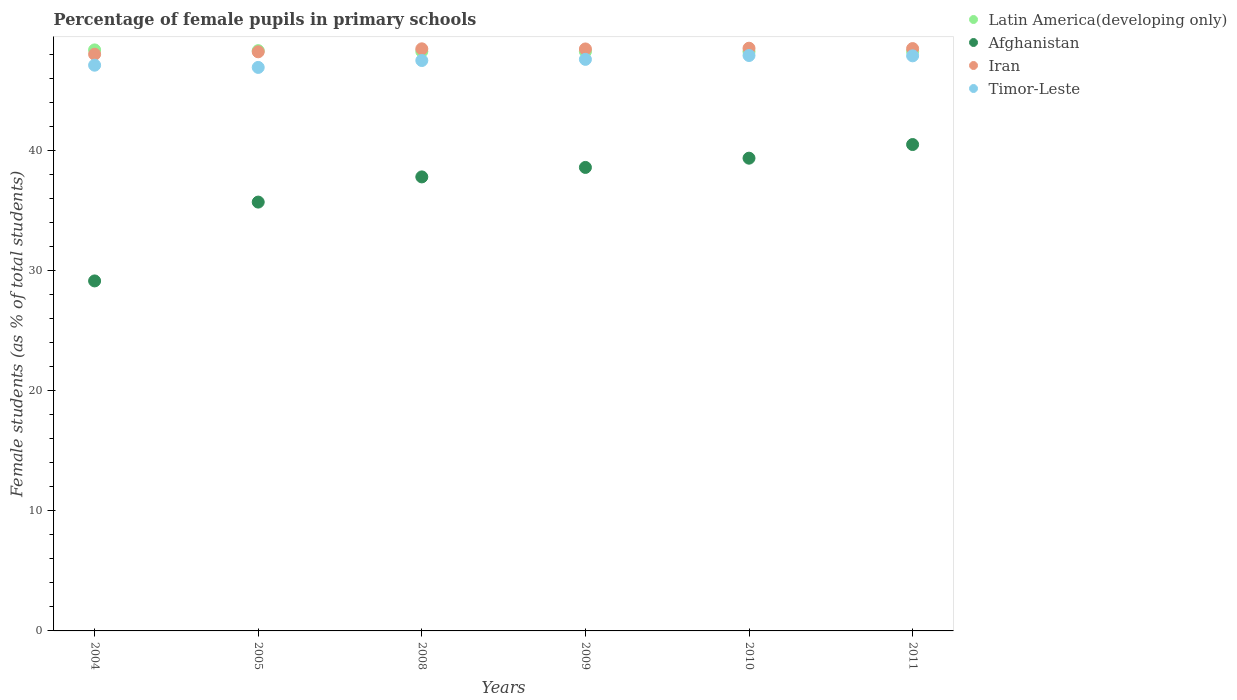Is the number of dotlines equal to the number of legend labels?
Keep it short and to the point. Yes. What is the percentage of female pupils in primary schools in Afghanistan in 2004?
Offer a very short reply. 29.13. Across all years, what is the maximum percentage of female pupils in primary schools in Timor-Leste?
Provide a succinct answer. 47.88. Across all years, what is the minimum percentage of female pupils in primary schools in Timor-Leste?
Provide a short and direct response. 46.89. In which year was the percentage of female pupils in primary schools in Latin America(developing only) maximum?
Give a very brief answer. 2004. In which year was the percentage of female pupils in primary schools in Timor-Leste minimum?
Keep it short and to the point. 2005. What is the total percentage of female pupils in primary schools in Iran in the graph?
Your response must be concise. 290.01. What is the difference between the percentage of female pupils in primary schools in Timor-Leste in 2009 and that in 2011?
Make the answer very short. -0.29. What is the difference between the percentage of female pupils in primary schools in Timor-Leste in 2004 and the percentage of female pupils in primary schools in Latin America(developing only) in 2010?
Your response must be concise. -1.14. What is the average percentage of female pupils in primary schools in Afghanistan per year?
Offer a terse response. 36.83. In the year 2008, what is the difference between the percentage of female pupils in primary schools in Timor-Leste and percentage of female pupils in primary schools in Afghanistan?
Offer a very short reply. 9.68. What is the ratio of the percentage of female pupils in primary schools in Iran in 2009 to that in 2011?
Make the answer very short. 1. Is the percentage of female pupils in primary schools in Afghanistan in 2004 less than that in 2009?
Provide a short and direct response. Yes. What is the difference between the highest and the second highest percentage of female pupils in primary schools in Timor-Leste?
Give a very brief answer. 0.03. What is the difference between the highest and the lowest percentage of female pupils in primary schools in Iran?
Your answer should be compact. 0.5. In how many years, is the percentage of female pupils in primary schools in Afghanistan greater than the average percentage of female pupils in primary schools in Afghanistan taken over all years?
Your response must be concise. 4. Is it the case that in every year, the sum of the percentage of female pupils in primary schools in Timor-Leste and percentage of female pupils in primary schools in Iran  is greater than the sum of percentage of female pupils in primary schools in Latin America(developing only) and percentage of female pupils in primary schools in Afghanistan?
Offer a terse response. Yes. Is it the case that in every year, the sum of the percentage of female pupils in primary schools in Timor-Leste and percentage of female pupils in primary schools in Iran  is greater than the percentage of female pupils in primary schools in Afghanistan?
Make the answer very short. Yes. How many years are there in the graph?
Ensure brevity in your answer.  6. Are the values on the major ticks of Y-axis written in scientific E-notation?
Keep it short and to the point. No. Does the graph contain any zero values?
Provide a succinct answer. No. Does the graph contain grids?
Your answer should be very brief. No. Where does the legend appear in the graph?
Your answer should be compact. Top right. How many legend labels are there?
Offer a very short reply. 4. What is the title of the graph?
Make the answer very short. Percentage of female pupils in primary schools. Does "Rwanda" appear as one of the legend labels in the graph?
Your answer should be compact. No. What is the label or title of the X-axis?
Keep it short and to the point. Years. What is the label or title of the Y-axis?
Your answer should be very brief. Female students (as % of total students). What is the Female students (as % of total students) of Latin America(developing only) in 2004?
Provide a succinct answer. 48.35. What is the Female students (as % of total students) in Afghanistan in 2004?
Make the answer very short. 29.13. What is the Female students (as % of total students) of Iran in 2004?
Give a very brief answer. 47.99. What is the Female students (as % of total students) in Timor-Leste in 2004?
Give a very brief answer. 47.08. What is the Female students (as % of total students) of Latin America(developing only) in 2005?
Your answer should be compact. 48.29. What is the Female students (as % of total students) of Afghanistan in 2005?
Make the answer very short. 35.69. What is the Female students (as % of total students) in Iran in 2005?
Provide a succinct answer. 48.19. What is the Female students (as % of total students) in Timor-Leste in 2005?
Your response must be concise. 46.89. What is the Female students (as % of total students) of Latin America(developing only) in 2008?
Give a very brief answer. 48.22. What is the Female students (as % of total students) of Afghanistan in 2008?
Your answer should be very brief. 37.78. What is the Female students (as % of total students) in Iran in 2008?
Provide a succinct answer. 48.44. What is the Female students (as % of total students) in Timor-Leste in 2008?
Your answer should be compact. 47.47. What is the Female students (as % of total students) of Latin America(developing only) in 2009?
Give a very brief answer. 48.21. What is the Female students (as % of total students) in Afghanistan in 2009?
Provide a succinct answer. 38.57. What is the Female students (as % of total students) in Iran in 2009?
Your answer should be very brief. 48.43. What is the Female students (as % of total students) of Timor-Leste in 2009?
Your answer should be very brief. 47.56. What is the Female students (as % of total students) in Latin America(developing only) in 2010?
Make the answer very short. 48.21. What is the Female students (as % of total students) of Afghanistan in 2010?
Offer a very short reply. 39.34. What is the Female students (as % of total students) of Iran in 2010?
Your answer should be compact. 48.49. What is the Female students (as % of total students) of Timor-Leste in 2010?
Ensure brevity in your answer.  47.88. What is the Female students (as % of total students) in Latin America(developing only) in 2011?
Provide a short and direct response. 48.22. What is the Female students (as % of total students) in Afghanistan in 2011?
Your answer should be compact. 40.48. What is the Female students (as % of total students) in Iran in 2011?
Offer a terse response. 48.46. What is the Female students (as % of total students) in Timor-Leste in 2011?
Make the answer very short. 47.86. Across all years, what is the maximum Female students (as % of total students) of Latin America(developing only)?
Your response must be concise. 48.35. Across all years, what is the maximum Female students (as % of total students) of Afghanistan?
Ensure brevity in your answer.  40.48. Across all years, what is the maximum Female students (as % of total students) in Iran?
Keep it short and to the point. 48.49. Across all years, what is the maximum Female students (as % of total students) in Timor-Leste?
Keep it short and to the point. 47.88. Across all years, what is the minimum Female students (as % of total students) in Latin America(developing only)?
Give a very brief answer. 48.21. Across all years, what is the minimum Female students (as % of total students) of Afghanistan?
Your answer should be compact. 29.13. Across all years, what is the minimum Female students (as % of total students) of Iran?
Ensure brevity in your answer.  47.99. Across all years, what is the minimum Female students (as % of total students) of Timor-Leste?
Offer a very short reply. 46.89. What is the total Female students (as % of total students) of Latin America(developing only) in the graph?
Make the answer very short. 289.51. What is the total Female students (as % of total students) of Afghanistan in the graph?
Offer a very short reply. 220.98. What is the total Female students (as % of total students) of Iran in the graph?
Give a very brief answer. 290.01. What is the total Female students (as % of total students) in Timor-Leste in the graph?
Give a very brief answer. 284.75. What is the difference between the Female students (as % of total students) of Latin America(developing only) in 2004 and that in 2005?
Your answer should be compact. 0.06. What is the difference between the Female students (as % of total students) of Afghanistan in 2004 and that in 2005?
Offer a very short reply. -6.56. What is the difference between the Female students (as % of total students) in Iran in 2004 and that in 2005?
Your response must be concise. -0.2. What is the difference between the Female students (as % of total students) of Timor-Leste in 2004 and that in 2005?
Keep it short and to the point. 0.18. What is the difference between the Female students (as % of total students) of Latin America(developing only) in 2004 and that in 2008?
Provide a succinct answer. 0.13. What is the difference between the Female students (as % of total students) of Afghanistan in 2004 and that in 2008?
Your answer should be very brief. -8.66. What is the difference between the Female students (as % of total students) in Iran in 2004 and that in 2008?
Keep it short and to the point. -0.45. What is the difference between the Female students (as % of total students) in Timor-Leste in 2004 and that in 2008?
Your response must be concise. -0.39. What is the difference between the Female students (as % of total students) in Latin America(developing only) in 2004 and that in 2009?
Give a very brief answer. 0.14. What is the difference between the Female students (as % of total students) of Afghanistan in 2004 and that in 2009?
Offer a terse response. -9.44. What is the difference between the Female students (as % of total students) of Iran in 2004 and that in 2009?
Your answer should be very brief. -0.44. What is the difference between the Female students (as % of total students) in Timor-Leste in 2004 and that in 2009?
Your answer should be compact. -0.49. What is the difference between the Female students (as % of total students) of Latin America(developing only) in 2004 and that in 2010?
Your answer should be compact. 0.14. What is the difference between the Female students (as % of total students) of Afghanistan in 2004 and that in 2010?
Offer a very short reply. -10.21. What is the difference between the Female students (as % of total students) in Iran in 2004 and that in 2010?
Make the answer very short. -0.5. What is the difference between the Female students (as % of total students) in Timor-Leste in 2004 and that in 2010?
Provide a succinct answer. -0.81. What is the difference between the Female students (as % of total students) in Latin America(developing only) in 2004 and that in 2011?
Ensure brevity in your answer.  0.13. What is the difference between the Female students (as % of total students) in Afghanistan in 2004 and that in 2011?
Offer a very short reply. -11.35. What is the difference between the Female students (as % of total students) of Iran in 2004 and that in 2011?
Provide a succinct answer. -0.47. What is the difference between the Female students (as % of total students) in Timor-Leste in 2004 and that in 2011?
Provide a short and direct response. -0.78. What is the difference between the Female students (as % of total students) of Latin America(developing only) in 2005 and that in 2008?
Give a very brief answer. 0.07. What is the difference between the Female students (as % of total students) in Afghanistan in 2005 and that in 2008?
Your response must be concise. -2.1. What is the difference between the Female students (as % of total students) in Iran in 2005 and that in 2008?
Provide a succinct answer. -0.25. What is the difference between the Female students (as % of total students) of Timor-Leste in 2005 and that in 2008?
Offer a very short reply. -0.57. What is the difference between the Female students (as % of total students) of Latin America(developing only) in 2005 and that in 2009?
Your response must be concise. 0.08. What is the difference between the Female students (as % of total students) of Afghanistan in 2005 and that in 2009?
Your answer should be compact. -2.88. What is the difference between the Female students (as % of total students) in Iran in 2005 and that in 2009?
Your answer should be compact. -0.24. What is the difference between the Female students (as % of total students) of Timor-Leste in 2005 and that in 2009?
Your response must be concise. -0.67. What is the difference between the Female students (as % of total students) in Latin America(developing only) in 2005 and that in 2010?
Offer a terse response. 0.08. What is the difference between the Female students (as % of total students) of Afghanistan in 2005 and that in 2010?
Keep it short and to the point. -3.65. What is the difference between the Female students (as % of total students) in Iran in 2005 and that in 2010?
Your answer should be very brief. -0.3. What is the difference between the Female students (as % of total students) in Timor-Leste in 2005 and that in 2010?
Keep it short and to the point. -0.99. What is the difference between the Female students (as % of total students) of Latin America(developing only) in 2005 and that in 2011?
Keep it short and to the point. 0.07. What is the difference between the Female students (as % of total students) of Afghanistan in 2005 and that in 2011?
Your response must be concise. -4.79. What is the difference between the Female students (as % of total students) of Iran in 2005 and that in 2011?
Your response must be concise. -0.27. What is the difference between the Female students (as % of total students) of Timor-Leste in 2005 and that in 2011?
Your answer should be compact. -0.96. What is the difference between the Female students (as % of total students) of Latin America(developing only) in 2008 and that in 2009?
Your answer should be very brief. 0.01. What is the difference between the Female students (as % of total students) of Afghanistan in 2008 and that in 2009?
Make the answer very short. -0.79. What is the difference between the Female students (as % of total students) in Iran in 2008 and that in 2009?
Ensure brevity in your answer.  0.01. What is the difference between the Female students (as % of total students) of Timor-Leste in 2008 and that in 2009?
Give a very brief answer. -0.1. What is the difference between the Female students (as % of total students) in Latin America(developing only) in 2008 and that in 2010?
Offer a terse response. 0.01. What is the difference between the Female students (as % of total students) of Afghanistan in 2008 and that in 2010?
Provide a succinct answer. -1.56. What is the difference between the Female students (as % of total students) of Iran in 2008 and that in 2010?
Provide a short and direct response. -0.05. What is the difference between the Female students (as % of total students) of Timor-Leste in 2008 and that in 2010?
Give a very brief answer. -0.42. What is the difference between the Female students (as % of total students) of Latin America(developing only) in 2008 and that in 2011?
Offer a terse response. -0. What is the difference between the Female students (as % of total students) in Afghanistan in 2008 and that in 2011?
Keep it short and to the point. -2.69. What is the difference between the Female students (as % of total students) of Iran in 2008 and that in 2011?
Provide a short and direct response. -0.02. What is the difference between the Female students (as % of total students) in Timor-Leste in 2008 and that in 2011?
Give a very brief answer. -0.39. What is the difference between the Female students (as % of total students) in Latin America(developing only) in 2009 and that in 2010?
Ensure brevity in your answer.  -0. What is the difference between the Female students (as % of total students) in Afghanistan in 2009 and that in 2010?
Offer a terse response. -0.77. What is the difference between the Female students (as % of total students) in Iran in 2009 and that in 2010?
Give a very brief answer. -0.06. What is the difference between the Female students (as % of total students) of Timor-Leste in 2009 and that in 2010?
Offer a very short reply. -0.32. What is the difference between the Female students (as % of total students) of Latin America(developing only) in 2009 and that in 2011?
Ensure brevity in your answer.  -0.01. What is the difference between the Female students (as % of total students) in Afghanistan in 2009 and that in 2011?
Offer a very short reply. -1.9. What is the difference between the Female students (as % of total students) of Iran in 2009 and that in 2011?
Provide a short and direct response. -0.03. What is the difference between the Female students (as % of total students) in Timor-Leste in 2009 and that in 2011?
Your response must be concise. -0.29. What is the difference between the Female students (as % of total students) of Latin America(developing only) in 2010 and that in 2011?
Provide a short and direct response. -0.01. What is the difference between the Female students (as % of total students) in Afghanistan in 2010 and that in 2011?
Offer a terse response. -1.13. What is the difference between the Female students (as % of total students) in Iran in 2010 and that in 2011?
Offer a terse response. 0.03. What is the difference between the Female students (as % of total students) in Timor-Leste in 2010 and that in 2011?
Your answer should be very brief. 0.03. What is the difference between the Female students (as % of total students) of Latin America(developing only) in 2004 and the Female students (as % of total students) of Afghanistan in 2005?
Ensure brevity in your answer.  12.66. What is the difference between the Female students (as % of total students) in Latin America(developing only) in 2004 and the Female students (as % of total students) in Iran in 2005?
Provide a short and direct response. 0.16. What is the difference between the Female students (as % of total students) in Latin America(developing only) in 2004 and the Female students (as % of total students) in Timor-Leste in 2005?
Provide a short and direct response. 1.46. What is the difference between the Female students (as % of total students) of Afghanistan in 2004 and the Female students (as % of total students) of Iran in 2005?
Give a very brief answer. -19.07. What is the difference between the Female students (as % of total students) of Afghanistan in 2004 and the Female students (as % of total students) of Timor-Leste in 2005?
Provide a short and direct response. -17.77. What is the difference between the Female students (as % of total students) of Iran in 2004 and the Female students (as % of total students) of Timor-Leste in 2005?
Make the answer very short. 1.1. What is the difference between the Female students (as % of total students) of Latin America(developing only) in 2004 and the Female students (as % of total students) of Afghanistan in 2008?
Offer a very short reply. 10.57. What is the difference between the Female students (as % of total students) in Latin America(developing only) in 2004 and the Female students (as % of total students) in Iran in 2008?
Ensure brevity in your answer.  -0.09. What is the difference between the Female students (as % of total students) in Latin America(developing only) in 2004 and the Female students (as % of total students) in Timor-Leste in 2008?
Your response must be concise. 0.88. What is the difference between the Female students (as % of total students) in Afghanistan in 2004 and the Female students (as % of total students) in Iran in 2008?
Offer a very short reply. -19.31. What is the difference between the Female students (as % of total students) of Afghanistan in 2004 and the Female students (as % of total students) of Timor-Leste in 2008?
Ensure brevity in your answer.  -18.34. What is the difference between the Female students (as % of total students) in Iran in 2004 and the Female students (as % of total students) in Timor-Leste in 2008?
Provide a succinct answer. 0.52. What is the difference between the Female students (as % of total students) of Latin America(developing only) in 2004 and the Female students (as % of total students) of Afghanistan in 2009?
Your answer should be compact. 9.78. What is the difference between the Female students (as % of total students) of Latin America(developing only) in 2004 and the Female students (as % of total students) of Iran in 2009?
Provide a succinct answer. -0.08. What is the difference between the Female students (as % of total students) in Latin America(developing only) in 2004 and the Female students (as % of total students) in Timor-Leste in 2009?
Your answer should be compact. 0.79. What is the difference between the Female students (as % of total students) in Afghanistan in 2004 and the Female students (as % of total students) in Iran in 2009?
Provide a succinct answer. -19.3. What is the difference between the Female students (as % of total students) of Afghanistan in 2004 and the Female students (as % of total students) of Timor-Leste in 2009?
Provide a succinct answer. -18.44. What is the difference between the Female students (as % of total students) of Iran in 2004 and the Female students (as % of total students) of Timor-Leste in 2009?
Your answer should be very brief. 0.43. What is the difference between the Female students (as % of total students) of Latin America(developing only) in 2004 and the Female students (as % of total students) of Afghanistan in 2010?
Provide a short and direct response. 9.01. What is the difference between the Female students (as % of total students) of Latin America(developing only) in 2004 and the Female students (as % of total students) of Iran in 2010?
Provide a short and direct response. -0.14. What is the difference between the Female students (as % of total students) in Latin America(developing only) in 2004 and the Female students (as % of total students) in Timor-Leste in 2010?
Your response must be concise. 0.47. What is the difference between the Female students (as % of total students) in Afghanistan in 2004 and the Female students (as % of total students) in Iran in 2010?
Your answer should be compact. -19.37. What is the difference between the Female students (as % of total students) in Afghanistan in 2004 and the Female students (as % of total students) in Timor-Leste in 2010?
Keep it short and to the point. -18.76. What is the difference between the Female students (as % of total students) in Iran in 2004 and the Female students (as % of total students) in Timor-Leste in 2010?
Provide a short and direct response. 0.11. What is the difference between the Female students (as % of total students) of Latin America(developing only) in 2004 and the Female students (as % of total students) of Afghanistan in 2011?
Give a very brief answer. 7.88. What is the difference between the Female students (as % of total students) in Latin America(developing only) in 2004 and the Female students (as % of total students) in Iran in 2011?
Offer a very short reply. -0.11. What is the difference between the Female students (as % of total students) in Latin America(developing only) in 2004 and the Female students (as % of total students) in Timor-Leste in 2011?
Provide a succinct answer. 0.49. What is the difference between the Female students (as % of total students) of Afghanistan in 2004 and the Female students (as % of total students) of Iran in 2011?
Offer a very short reply. -19.34. What is the difference between the Female students (as % of total students) in Afghanistan in 2004 and the Female students (as % of total students) in Timor-Leste in 2011?
Your response must be concise. -18.73. What is the difference between the Female students (as % of total students) in Iran in 2004 and the Female students (as % of total students) in Timor-Leste in 2011?
Offer a terse response. 0.13. What is the difference between the Female students (as % of total students) of Latin America(developing only) in 2005 and the Female students (as % of total students) of Afghanistan in 2008?
Your response must be concise. 10.51. What is the difference between the Female students (as % of total students) of Latin America(developing only) in 2005 and the Female students (as % of total students) of Iran in 2008?
Keep it short and to the point. -0.15. What is the difference between the Female students (as % of total students) of Latin America(developing only) in 2005 and the Female students (as % of total students) of Timor-Leste in 2008?
Offer a very short reply. 0.82. What is the difference between the Female students (as % of total students) in Afghanistan in 2005 and the Female students (as % of total students) in Iran in 2008?
Your answer should be very brief. -12.75. What is the difference between the Female students (as % of total students) of Afghanistan in 2005 and the Female students (as % of total students) of Timor-Leste in 2008?
Your answer should be very brief. -11.78. What is the difference between the Female students (as % of total students) in Iran in 2005 and the Female students (as % of total students) in Timor-Leste in 2008?
Give a very brief answer. 0.73. What is the difference between the Female students (as % of total students) of Latin America(developing only) in 2005 and the Female students (as % of total students) of Afghanistan in 2009?
Give a very brief answer. 9.72. What is the difference between the Female students (as % of total students) of Latin America(developing only) in 2005 and the Female students (as % of total students) of Iran in 2009?
Provide a succinct answer. -0.14. What is the difference between the Female students (as % of total students) of Latin America(developing only) in 2005 and the Female students (as % of total students) of Timor-Leste in 2009?
Provide a short and direct response. 0.72. What is the difference between the Female students (as % of total students) in Afghanistan in 2005 and the Female students (as % of total students) in Iran in 2009?
Your response must be concise. -12.74. What is the difference between the Female students (as % of total students) of Afghanistan in 2005 and the Female students (as % of total students) of Timor-Leste in 2009?
Offer a terse response. -11.88. What is the difference between the Female students (as % of total students) in Iran in 2005 and the Female students (as % of total students) in Timor-Leste in 2009?
Your answer should be compact. 0.63. What is the difference between the Female students (as % of total students) of Latin America(developing only) in 2005 and the Female students (as % of total students) of Afghanistan in 2010?
Make the answer very short. 8.95. What is the difference between the Female students (as % of total students) in Latin America(developing only) in 2005 and the Female students (as % of total students) in Iran in 2010?
Give a very brief answer. -0.2. What is the difference between the Female students (as % of total students) in Latin America(developing only) in 2005 and the Female students (as % of total students) in Timor-Leste in 2010?
Make the answer very short. 0.4. What is the difference between the Female students (as % of total students) of Afghanistan in 2005 and the Female students (as % of total students) of Iran in 2010?
Offer a very short reply. -12.81. What is the difference between the Female students (as % of total students) in Afghanistan in 2005 and the Female students (as % of total students) in Timor-Leste in 2010?
Make the answer very short. -12.2. What is the difference between the Female students (as % of total students) in Iran in 2005 and the Female students (as % of total students) in Timor-Leste in 2010?
Your answer should be compact. 0.31. What is the difference between the Female students (as % of total students) in Latin America(developing only) in 2005 and the Female students (as % of total students) in Afghanistan in 2011?
Ensure brevity in your answer.  7.81. What is the difference between the Female students (as % of total students) in Latin America(developing only) in 2005 and the Female students (as % of total students) in Iran in 2011?
Offer a terse response. -0.17. What is the difference between the Female students (as % of total students) in Latin America(developing only) in 2005 and the Female students (as % of total students) in Timor-Leste in 2011?
Provide a succinct answer. 0.43. What is the difference between the Female students (as % of total students) of Afghanistan in 2005 and the Female students (as % of total students) of Iran in 2011?
Provide a succinct answer. -12.77. What is the difference between the Female students (as % of total students) of Afghanistan in 2005 and the Female students (as % of total students) of Timor-Leste in 2011?
Make the answer very short. -12.17. What is the difference between the Female students (as % of total students) of Iran in 2005 and the Female students (as % of total students) of Timor-Leste in 2011?
Your response must be concise. 0.34. What is the difference between the Female students (as % of total students) of Latin America(developing only) in 2008 and the Female students (as % of total students) of Afghanistan in 2009?
Your answer should be compact. 9.65. What is the difference between the Female students (as % of total students) of Latin America(developing only) in 2008 and the Female students (as % of total students) of Iran in 2009?
Give a very brief answer. -0.21. What is the difference between the Female students (as % of total students) in Latin America(developing only) in 2008 and the Female students (as % of total students) in Timor-Leste in 2009?
Your answer should be compact. 0.66. What is the difference between the Female students (as % of total students) in Afghanistan in 2008 and the Female students (as % of total students) in Iran in 2009?
Offer a very short reply. -10.65. What is the difference between the Female students (as % of total students) in Afghanistan in 2008 and the Female students (as % of total students) in Timor-Leste in 2009?
Keep it short and to the point. -9.78. What is the difference between the Female students (as % of total students) of Iran in 2008 and the Female students (as % of total students) of Timor-Leste in 2009?
Offer a terse response. 0.88. What is the difference between the Female students (as % of total students) of Latin America(developing only) in 2008 and the Female students (as % of total students) of Afghanistan in 2010?
Make the answer very short. 8.88. What is the difference between the Female students (as % of total students) of Latin America(developing only) in 2008 and the Female students (as % of total students) of Iran in 2010?
Your response must be concise. -0.27. What is the difference between the Female students (as % of total students) in Latin America(developing only) in 2008 and the Female students (as % of total students) in Timor-Leste in 2010?
Your answer should be very brief. 0.34. What is the difference between the Female students (as % of total students) of Afghanistan in 2008 and the Female students (as % of total students) of Iran in 2010?
Provide a succinct answer. -10.71. What is the difference between the Female students (as % of total students) of Afghanistan in 2008 and the Female students (as % of total students) of Timor-Leste in 2010?
Provide a short and direct response. -10.1. What is the difference between the Female students (as % of total students) of Iran in 2008 and the Female students (as % of total students) of Timor-Leste in 2010?
Make the answer very short. 0.56. What is the difference between the Female students (as % of total students) of Latin America(developing only) in 2008 and the Female students (as % of total students) of Afghanistan in 2011?
Offer a very short reply. 7.75. What is the difference between the Female students (as % of total students) in Latin America(developing only) in 2008 and the Female students (as % of total students) in Iran in 2011?
Your answer should be very brief. -0.24. What is the difference between the Female students (as % of total students) of Latin America(developing only) in 2008 and the Female students (as % of total students) of Timor-Leste in 2011?
Offer a terse response. 0.36. What is the difference between the Female students (as % of total students) of Afghanistan in 2008 and the Female students (as % of total students) of Iran in 2011?
Offer a very short reply. -10.68. What is the difference between the Female students (as % of total students) in Afghanistan in 2008 and the Female students (as % of total students) in Timor-Leste in 2011?
Offer a very short reply. -10.08. What is the difference between the Female students (as % of total students) of Iran in 2008 and the Female students (as % of total students) of Timor-Leste in 2011?
Ensure brevity in your answer.  0.58. What is the difference between the Female students (as % of total students) in Latin America(developing only) in 2009 and the Female students (as % of total students) in Afghanistan in 2010?
Your answer should be compact. 8.87. What is the difference between the Female students (as % of total students) of Latin America(developing only) in 2009 and the Female students (as % of total students) of Iran in 2010?
Your answer should be very brief. -0.28. What is the difference between the Female students (as % of total students) of Latin America(developing only) in 2009 and the Female students (as % of total students) of Timor-Leste in 2010?
Your response must be concise. 0.33. What is the difference between the Female students (as % of total students) in Afghanistan in 2009 and the Female students (as % of total students) in Iran in 2010?
Your response must be concise. -9.92. What is the difference between the Female students (as % of total students) in Afghanistan in 2009 and the Female students (as % of total students) in Timor-Leste in 2010?
Give a very brief answer. -9.31. What is the difference between the Female students (as % of total students) in Iran in 2009 and the Female students (as % of total students) in Timor-Leste in 2010?
Provide a short and direct response. 0.55. What is the difference between the Female students (as % of total students) of Latin America(developing only) in 2009 and the Female students (as % of total students) of Afghanistan in 2011?
Offer a terse response. 7.74. What is the difference between the Female students (as % of total students) of Latin America(developing only) in 2009 and the Female students (as % of total students) of Iran in 2011?
Your answer should be compact. -0.25. What is the difference between the Female students (as % of total students) of Latin America(developing only) in 2009 and the Female students (as % of total students) of Timor-Leste in 2011?
Keep it short and to the point. 0.35. What is the difference between the Female students (as % of total students) of Afghanistan in 2009 and the Female students (as % of total students) of Iran in 2011?
Provide a short and direct response. -9.89. What is the difference between the Female students (as % of total students) of Afghanistan in 2009 and the Female students (as % of total students) of Timor-Leste in 2011?
Your answer should be very brief. -9.29. What is the difference between the Female students (as % of total students) in Iran in 2009 and the Female students (as % of total students) in Timor-Leste in 2011?
Provide a short and direct response. 0.57. What is the difference between the Female students (as % of total students) of Latin America(developing only) in 2010 and the Female students (as % of total students) of Afghanistan in 2011?
Your response must be concise. 7.74. What is the difference between the Female students (as % of total students) of Latin America(developing only) in 2010 and the Female students (as % of total students) of Iran in 2011?
Offer a very short reply. -0.25. What is the difference between the Female students (as % of total students) of Latin America(developing only) in 2010 and the Female students (as % of total students) of Timor-Leste in 2011?
Make the answer very short. 0.36. What is the difference between the Female students (as % of total students) in Afghanistan in 2010 and the Female students (as % of total students) in Iran in 2011?
Your answer should be very brief. -9.12. What is the difference between the Female students (as % of total students) in Afghanistan in 2010 and the Female students (as % of total students) in Timor-Leste in 2011?
Your answer should be compact. -8.52. What is the difference between the Female students (as % of total students) of Iran in 2010 and the Female students (as % of total students) of Timor-Leste in 2011?
Offer a very short reply. 0.63. What is the average Female students (as % of total students) in Latin America(developing only) per year?
Your answer should be compact. 48.25. What is the average Female students (as % of total students) of Afghanistan per year?
Your answer should be compact. 36.83. What is the average Female students (as % of total students) in Iran per year?
Ensure brevity in your answer.  48.33. What is the average Female students (as % of total students) in Timor-Leste per year?
Make the answer very short. 47.46. In the year 2004, what is the difference between the Female students (as % of total students) in Latin America(developing only) and Female students (as % of total students) in Afghanistan?
Your answer should be very brief. 19.23. In the year 2004, what is the difference between the Female students (as % of total students) of Latin America(developing only) and Female students (as % of total students) of Iran?
Your answer should be very brief. 0.36. In the year 2004, what is the difference between the Female students (as % of total students) in Latin America(developing only) and Female students (as % of total students) in Timor-Leste?
Provide a short and direct response. 1.27. In the year 2004, what is the difference between the Female students (as % of total students) of Afghanistan and Female students (as % of total students) of Iran?
Make the answer very short. -18.86. In the year 2004, what is the difference between the Female students (as % of total students) in Afghanistan and Female students (as % of total students) in Timor-Leste?
Your response must be concise. -17.95. In the year 2004, what is the difference between the Female students (as % of total students) of Iran and Female students (as % of total students) of Timor-Leste?
Your answer should be very brief. 0.91. In the year 2005, what is the difference between the Female students (as % of total students) in Latin America(developing only) and Female students (as % of total students) in Afghanistan?
Offer a terse response. 12.6. In the year 2005, what is the difference between the Female students (as % of total students) in Latin America(developing only) and Female students (as % of total students) in Iran?
Make the answer very short. 0.1. In the year 2005, what is the difference between the Female students (as % of total students) in Latin America(developing only) and Female students (as % of total students) in Timor-Leste?
Keep it short and to the point. 1.4. In the year 2005, what is the difference between the Female students (as % of total students) of Afghanistan and Female students (as % of total students) of Iran?
Offer a terse response. -12.51. In the year 2005, what is the difference between the Female students (as % of total students) in Afghanistan and Female students (as % of total students) in Timor-Leste?
Make the answer very short. -11.21. In the year 2005, what is the difference between the Female students (as % of total students) in Iran and Female students (as % of total students) in Timor-Leste?
Provide a succinct answer. 1.3. In the year 2008, what is the difference between the Female students (as % of total students) in Latin America(developing only) and Female students (as % of total students) in Afghanistan?
Your answer should be very brief. 10.44. In the year 2008, what is the difference between the Female students (as % of total students) in Latin America(developing only) and Female students (as % of total students) in Iran?
Make the answer very short. -0.22. In the year 2008, what is the difference between the Female students (as % of total students) of Latin America(developing only) and Female students (as % of total students) of Timor-Leste?
Make the answer very short. 0.76. In the year 2008, what is the difference between the Female students (as % of total students) in Afghanistan and Female students (as % of total students) in Iran?
Make the answer very short. -10.66. In the year 2008, what is the difference between the Female students (as % of total students) of Afghanistan and Female students (as % of total students) of Timor-Leste?
Provide a short and direct response. -9.68. In the year 2008, what is the difference between the Female students (as % of total students) in Iran and Female students (as % of total students) in Timor-Leste?
Offer a very short reply. 0.97. In the year 2009, what is the difference between the Female students (as % of total students) in Latin America(developing only) and Female students (as % of total students) in Afghanistan?
Offer a very short reply. 9.64. In the year 2009, what is the difference between the Female students (as % of total students) in Latin America(developing only) and Female students (as % of total students) in Iran?
Your response must be concise. -0.22. In the year 2009, what is the difference between the Female students (as % of total students) of Latin America(developing only) and Female students (as % of total students) of Timor-Leste?
Give a very brief answer. 0.65. In the year 2009, what is the difference between the Female students (as % of total students) in Afghanistan and Female students (as % of total students) in Iran?
Your response must be concise. -9.86. In the year 2009, what is the difference between the Female students (as % of total students) of Afghanistan and Female students (as % of total students) of Timor-Leste?
Your response must be concise. -8.99. In the year 2009, what is the difference between the Female students (as % of total students) of Iran and Female students (as % of total students) of Timor-Leste?
Give a very brief answer. 0.87. In the year 2010, what is the difference between the Female students (as % of total students) of Latin America(developing only) and Female students (as % of total students) of Afghanistan?
Your response must be concise. 8.87. In the year 2010, what is the difference between the Female students (as % of total students) of Latin America(developing only) and Female students (as % of total students) of Iran?
Your response must be concise. -0.28. In the year 2010, what is the difference between the Female students (as % of total students) of Latin America(developing only) and Female students (as % of total students) of Timor-Leste?
Your answer should be compact. 0.33. In the year 2010, what is the difference between the Female students (as % of total students) in Afghanistan and Female students (as % of total students) in Iran?
Provide a short and direct response. -9.15. In the year 2010, what is the difference between the Female students (as % of total students) in Afghanistan and Female students (as % of total students) in Timor-Leste?
Give a very brief answer. -8.54. In the year 2010, what is the difference between the Female students (as % of total students) in Iran and Female students (as % of total students) in Timor-Leste?
Keep it short and to the point. 0.61. In the year 2011, what is the difference between the Female students (as % of total students) of Latin America(developing only) and Female students (as % of total students) of Afghanistan?
Keep it short and to the point. 7.75. In the year 2011, what is the difference between the Female students (as % of total students) in Latin America(developing only) and Female students (as % of total students) in Iran?
Ensure brevity in your answer.  -0.24. In the year 2011, what is the difference between the Female students (as % of total students) of Latin America(developing only) and Female students (as % of total students) of Timor-Leste?
Offer a terse response. 0.37. In the year 2011, what is the difference between the Female students (as % of total students) of Afghanistan and Female students (as % of total students) of Iran?
Keep it short and to the point. -7.99. In the year 2011, what is the difference between the Female students (as % of total students) in Afghanistan and Female students (as % of total students) in Timor-Leste?
Give a very brief answer. -7.38. In the year 2011, what is the difference between the Female students (as % of total students) of Iran and Female students (as % of total students) of Timor-Leste?
Provide a succinct answer. 0.6. What is the ratio of the Female students (as % of total students) of Latin America(developing only) in 2004 to that in 2005?
Give a very brief answer. 1. What is the ratio of the Female students (as % of total students) in Afghanistan in 2004 to that in 2005?
Your answer should be compact. 0.82. What is the ratio of the Female students (as % of total students) of Iran in 2004 to that in 2005?
Give a very brief answer. 1. What is the ratio of the Female students (as % of total students) in Latin America(developing only) in 2004 to that in 2008?
Your answer should be compact. 1. What is the ratio of the Female students (as % of total students) in Afghanistan in 2004 to that in 2008?
Offer a very short reply. 0.77. What is the ratio of the Female students (as % of total students) of Iran in 2004 to that in 2008?
Provide a short and direct response. 0.99. What is the ratio of the Female students (as % of total students) in Latin America(developing only) in 2004 to that in 2009?
Make the answer very short. 1. What is the ratio of the Female students (as % of total students) in Afghanistan in 2004 to that in 2009?
Your answer should be compact. 0.76. What is the ratio of the Female students (as % of total students) of Iran in 2004 to that in 2009?
Your response must be concise. 0.99. What is the ratio of the Female students (as % of total students) of Timor-Leste in 2004 to that in 2009?
Ensure brevity in your answer.  0.99. What is the ratio of the Female students (as % of total students) in Latin America(developing only) in 2004 to that in 2010?
Keep it short and to the point. 1. What is the ratio of the Female students (as % of total students) of Afghanistan in 2004 to that in 2010?
Keep it short and to the point. 0.74. What is the ratio of the Female students (as % of total students) of Timor-Leste in 2004 to that in 2010?
Offer a terse response. 0.98. What is the ratio of the Female students (as % of total students) in Latin America(developing only) in 2004 to that in 2011?
Give a very brief answer. 1. What is the ratio of the Female students (as % of total students) in Afghanistan in 2004 to that in 2011?
Give a very brief answer. 0.72. What is the ratio of the Female students (as % of total students) of Iran in 2004 to that in 2011?
Offer a terse response. 0.99. What is the ratio of the Female students (as % of total students) in Timor-Leste in 2004 to that in 2011?
Your response must be concise. 0.98. What is the ratio of the Female students (as % of total students) in Afghanistan in 2005 to that in 2008?
Your answer should be compact. 0.94. What is the ratio of the Female students (as % of total students) in Timor-Leste in 2005 to that in 2008?
Ensure brevity in your answer.  0.99. What is the ratio of the Female students (as % of total students) of Latin America(developing only) in 2005 to that in 2009?
Your response must be concise. 1. What is the ratio of the Female students (as % of total students) of Afghanistan in 2005 to that in 2009?
Your answer should be very brief. 0.93. What is the ratio of the Female students (as % of total students) in Timor-Leste in 2005 to that in 2009?
Provide a short and direct response. 0.99. What is the ratio of the Female students (as % of total students) of Afghanistan in 2005 to that in 2010?
Ensure brevity in your answer.  0.91. What is the ratio of the Female students (as % of total students) of Timor-Leste in 2005 to that in 2010?
Your answer should be very brief. 0.98. What is the ratio of the Female students (as % of total students) of Latin America(developing only) in 2005 to that in 2011?
Make the answer very short. 1. What is the ratio of the Female students (as % of total students) of Afghanistan in 2005 to that in 2011?
Offer a very short reply. 0.88. What is the ratio of the Female students (as % of total students) of Iran in 2005 to that in 2011?
Provide a short and direct response. 0.99. What is the ratio of the Female students (as % of total students) in Timor-Leste in 2005 to that in 2011?
Offer a very short reply. 0.98. What is the ratio of the Female students (as % of total students) in Afghanistan in 2008 to that in 2009?
Make the answer very short. 0.98. What is the ratio of the Female students (as % of total students) of Iran in 2008 to that in 2009?
Your answer should be compact. 1. What is the ratio of the Female students (as % of total students) of Latin America(developing only) in 2008 to that in 2010?
Offer a terse response. 1. What is the ratio of the Female students (as % of total students) of Afghanistan in 2008 to that in 2010?
Offer a very short reply. 0.96. What is the ratio of the Female students (as % of total students) in Iran in 2008 to that in 2010?
Make the answer very short. 1. What is the ratio of the Female students (as % of total students) in Timor-Leste in 2008 to that in 2010?
Ensure brevity in your answer.  0.99. What is the ratio of the Female students (as % of total students) of Afghanistan in 2008 to that in 2011?
Provide a short and direct response. 0.93. What is the ratio of the Female students (as % of total students) of Iran in 2008 to that in 2011?
Keep it short and to the point. 1. What is the ratio of the Female students (as % of total students) in Latin America(developing only) in 2009 to that in 2010?
Ensure brevity in your answer.  1. What is the ratio of the Female students (as % of total students) of Afghanistan in 2009 to that in 2010?
Offer a very short reply. 0.98. What is the ratio of the Female students (as % of total students) of Iran in 2009 to that in 2010?
Make the answer very short. 1. What is the ratio of the Female students (as % of total students) of Latin America(developing only) in 2009 to that in 2011?
Provide a short and direct response. 1. What is the ratio of the Female students (as % of total students) in Afghanistan in 2009 to that in 2011?
Your response must be concise. 0.95. What is the ratio of the Female students (as % of total students) of Afghanistan in 2010 to that in 2011?
Make the answer very short. 0.97. What is the ratio of the Female students (as % of total students) in Iran in 2010 to that in 2011?
Make the answer very short. 1. What is the difference between the highest and the second highest Female students (as % of total students) in Latin America(developing only)?
Your answer should be compact. 0.06. What is the difference between the highest and the second highest Female students (as % of total students) in Afghanistan?
Your answer should be very brief. 1.13. What is the difference between the highest and the second highest Female students (as % of total students) of Iran?
Your answer should be very brief. 0.03. What is the difference between the highest and the second highest Female students (as % of total students) in Timor-Leste?
Ensure brevity in your answer.  0.03. What is the difference between the highest and the lowest Female students (as % of total students) of Latin America(developing only)?
Make the answer very short. 0.14. What is the difference between the highest and the lowest Female students (as % of total students) of Afghanistan?
Offer a very short reply. 11.35. What is the difference between the highest and the lowest Female students (as % of total students) of Iran?
Ensure brevity in your answer.  0.5. What is the difference between the highest and the lowest Female students (as % of total students) of Timor-Leste?
Provide a short and direct response. 0.99. 